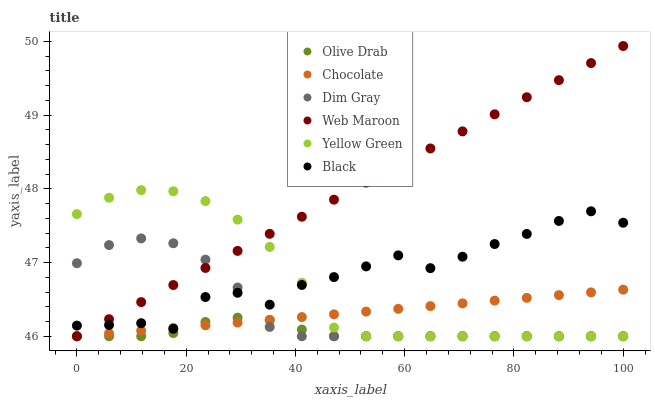Does Olive Drab have the minimum area under the curve?
Answer yes or no. Yes. Does Web Maroon have the maximum area under the curve?
Answer yes or no. Yes. Does Yellow Green have the minimum area under the curve?
Answer yes or no. No. Does Yellow Green have the maximum area under the curve?
Answer yes or no. No. Is Chocolate the smoothest?
Answer yes or no. Yes. Is Black the roughest?
Answer yes or no. Yes. Is Yellow Green the smoothest?
Answer yes or no. No. Is Yellow Green the roughest?
Answer yes or no. No. Does Dim Gray have the lowest value?
Answer yes or no. Yes. Does Black have the lowest value?
Answer yes or no. No. Does Web Maroon have the highest value?
Answer yes or no. Yes. Does Yellow Green have the highest value?
Answer yes or no. No. Is Olive Drab less than Black?
Answer yes or no. Yes. Is Black greater than Olive Drab?
Answer yes or no. Yes. Does Dim Gray intersect Web Maroon?
Answer yes or no. Yes. Is Dim Gray less than Web Maroon?
Answer yes or no. No. Is Dim Gray greater than Web Maroon?
Answer yes or no. No. Does Olive Drab intersect Black?
Answer yes or no. No. 